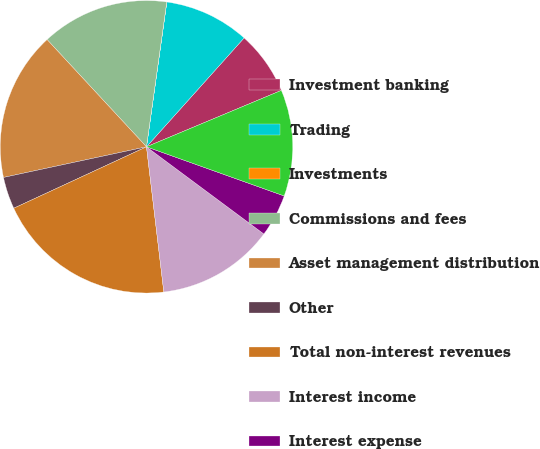Convert chart to OTSL. <chart><loc_0><loc_0><loc_500><loc_500><pie_chart><fcel>Investment banking<fcel>Trading<fcel>Investments<fcel>Commissions and fees<fcel>Asset management distribution<fcel>Other<fcel>Total non-interest revenues<fcel>Interest income<fcel>Interest expense<fcel>Net interest<nl><fcel>7.06%<fcel>9.41%<fcel>0.01%<fcel>14.11%<fcel>16.46%<fcel>3.54%<fcel>19.99%<fcel>12.94%<fcel>4.71%<fcel>11.76%<nl></chart> 